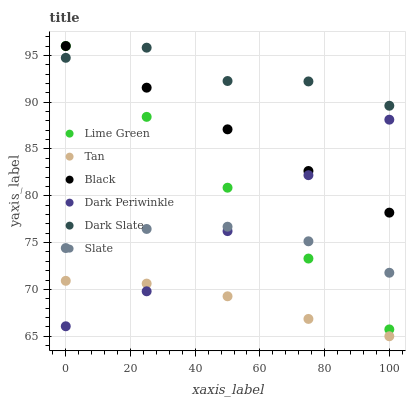Does Tan have the minimum area under the curve?
Answer yes or no. Yes. Does Dark Slate have the maximum area under the curve?
Answer yes or no. Yes. Does Black have the minimum area under the curve?
Answer yes or no. No. Does Black have the maximum area under the curve?
Answer yes or no. No. Is Black the smoothest?
Answer yes or no. Yes. Is Dark Slate the roughest?
Answer yes or no. Yes. Is Dark Slate the smoothest?
Answer yes or no. No. Is Black the roughest?
Answer yes or no. No. Does Tan have the lowest value?
Answer yes or no. Yes. Does Black have the lowest value?
Answer yes or no. No. Does Lime Green have the highest value?
Answer yes or no. Yes. Does Dark Slate have the highest value?
Answer yes or no. No. Is Tan less than Dark Slate?
Answer yes or no. Yes. Is Lime Green greater than Tan?
Answer yes or no. Yes. Does Lime Green intersect Dark Slate?
Answer yes or no. Yes. Is Lime Green less than Dark Slate?
Answer yes or no. No. Is Lime Green greater than Dark Slate?
Answer yes or no. No. Does Tan intersect Dark Slate?
Answer yes or no. No. 